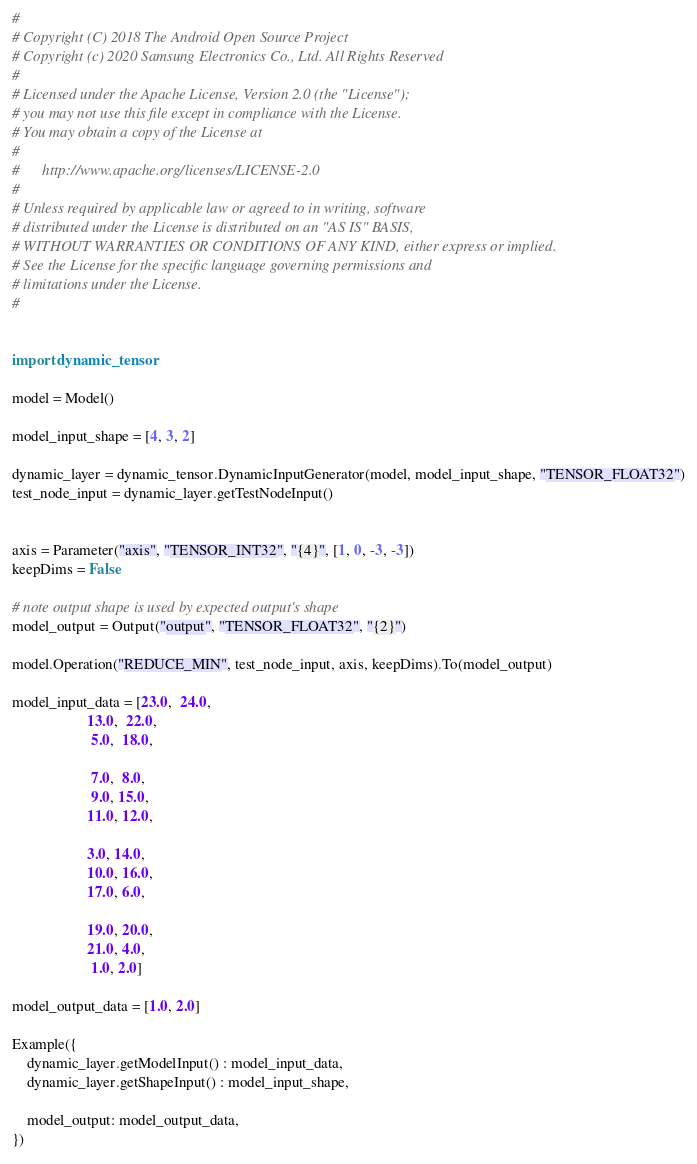Convert code to text. <code><loc_0><loc_0><loc_500><loc_500><_Python_>#
# Copyright (C) 2018 The Android Open Source Project
# Copyright (c) 2020 Samsung Electronics Co., Ltd. All Rights Reserved
#
# Licensed under the Apache License, Version 2.0 (the "License");
# you may not use this file except in compliance with the License.
# You may obtain a copy of the License at
#
#      http://www.apache.org/licenses/LICENSE-2.0
#
# Unless required by applicable law or agreed to in writing, software
# distributed under the License is distributed on an "AS IS" BASIS,
# WITHOUT WARRANTIES OR CONDITIONS OF ANY KIND, either express or implied.
# See the License for the specific language governing permissions and
# limitations under the License.
#


import dynamic_tensor

model = Model()

model_input_shape = [4, 3, 2]

dynamic_layer = dynamic_tensor.DynamicInputGenerator(model, model_input_shape, "TENSOR_FLOAT32")
test_node_input = dynamic_layer.getTestNodeInput()


axis = Parameter("axis", "TENSOR_INT32", "{4}", [1, 0, -3, -3])
keepDims = False

# note output shape is used by expected output's shape
model_output = Output("output", "TENSOR_FLOAT32", "{2}")

model.Operation("REDUCE_MIN", test_node_input, axis, keepDims).To(model_output)

model_input_data = [23.0,  24.0,
                    13.0,  22.0,
                     5.0,  18.0,

                     7.0,  8.0,
                     9.0, 15.0,
                    11.0, 12.0,

                    3.0, 14.0,
                    10.0, 16.0,
                    17.0, 6.0,

                    19.0, 20.0,
                    21.0, 4.0,
                     1.0, 2.0]

model_output_data = [1.0, 2.0]

Example({
    dynamic_layer.getModelInput() : model_input_data,
    dynamic_layer.getShapeInput() : model_input_shape,

    model_output: model_output_data,
})
</code> 